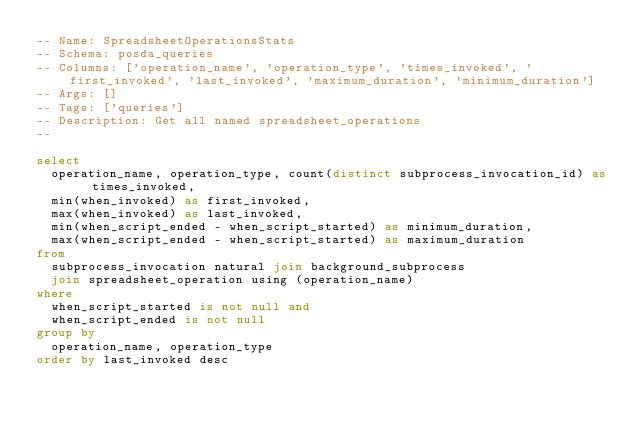<code> <loc_0><loc_0><loc_500><loc_500><_SQL_>-- Name: SpreadsheetOperationsStats
-- Schema: posda_queries
-- Columns: ['operation_name', 'operation_type', 'times_invoked', 'first_invoked', 'last_invoked', 'maximum_duration', 'minimum_duration']
-- Args: []
-- Tags: ['queries']
-- Description: Get all named spreadsheet_operations
--

select
  operation_name, operation_type, count(distinct subprocess_invocation_id) as times_invoked,
  min(when_invoked) as first_invoked,
  max(when_invoked) as last_invoked,
  min(when_script_ended - when_script_started) as minimum_duration,
  max(when_script_ended - when_script_started) as maximum_duration
from
  subprocess_invocation natural join background_subprocess
  join spreadsheet_operation using (operation_name)
where
  when_script_started is not null and
  when_script_ended is not null
group by 
  operation_name, operation_type
order by last_invoked desc</code> 